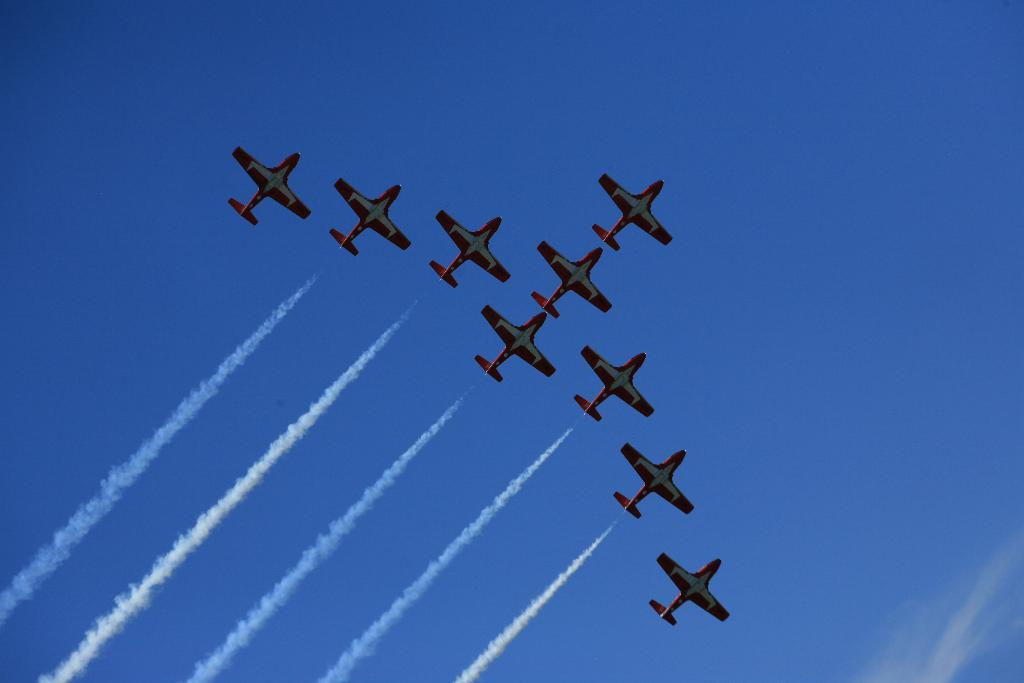What is the main subject of the image? The main subject of the image is airplanes. Where are the airplanes located in the image? The airplanes are in the air. What can be seen in the background of the image? The sky is visible in the background of the image. What type of magic is being performed by the airplanes in the image? There is no magic being performed by the airplanes in the image; they are simply flying in the sky. Can you tell me how many light bulbs are visible in the image? There are no light bulbs present in the image. 